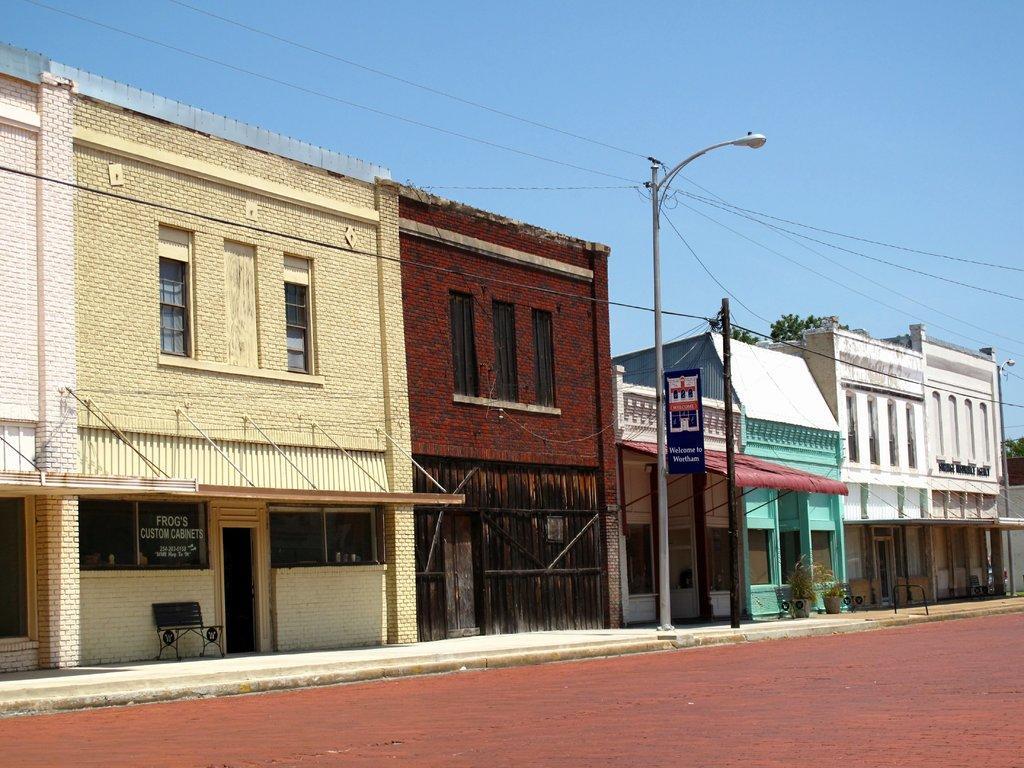In one or two sentences, can you explain what this image depicts? In the foreground of this image, there is a road. In the middle, there are buildings and few poles. At the top, there is the sky. 